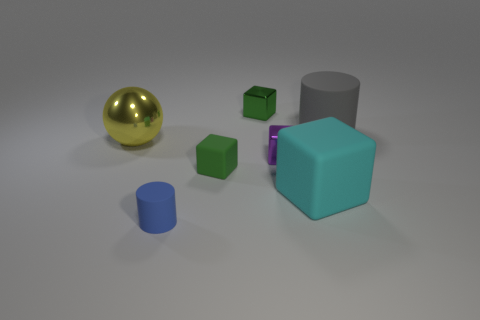Add 2 metallic balls. How many objects exist? 9 Subtract all cubes. How many objects are left? 3 Subtract 2 green blocks. How many objects are left? 5 Subtract all big shiny balls. Subtract all large gray matte cylinders. How many objects are left? 5 Add 4 big metallic objects. How many big metallic objects are left? 5 Add 7 small red metallic spheres. How many small red metallic spheres exist? 7 